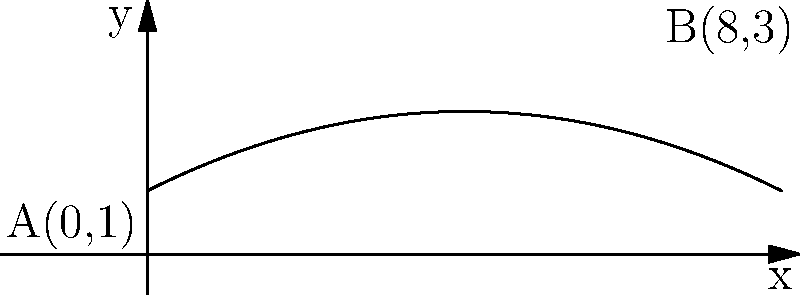A professional bowler releases a bowling ball, and its trajectory can be modeled by the parabolic equation $y = -0.05x^2 + 0.5x + 1$, where $x$ is the horizontal distance traveled in feet and $y$ is the height of the ball in feet. If the ball travels 8 feet horizontally before hitting the lane, what is the maximum height reached by the ball during its flight? To find the maximum height of the parabolic trajectory, we need to follow these steps:

1) The general form of a parabola is $y = ax^2 + bx + c$, where $a$, $b$, and $c$ are constants, and $a < 0$ for a parabola that opens downward.

2) In our equation $y = -0.05x^2 + 0.5x + 1$, we have:
   $a = -0.05$
   $b = 0.5$
   $c = 1$

3) For a parabola, the x-coordinate of the vertex (which corresponds to the maximum height) is given by $x = -\frac{b}{2a}$

4) Substituting our values:
   $x = -\frac{0.5}{2(-0.05)} = -\frac{0.5}{-0.1} = 5$

5) To find the maximum height, we substitute this x-value back into our original equation:

   $y = -0.05(5)^2 + 0.5(5) + 1$
   $y = -0.05(25) + 2.5 + 1$
   $y = -1.25 + 2.5 + 1$
   $y = 2.25$

Therefore, the maximum height reached by the bowling ball is 2.25 feet.
Answer: 2.25 feet 